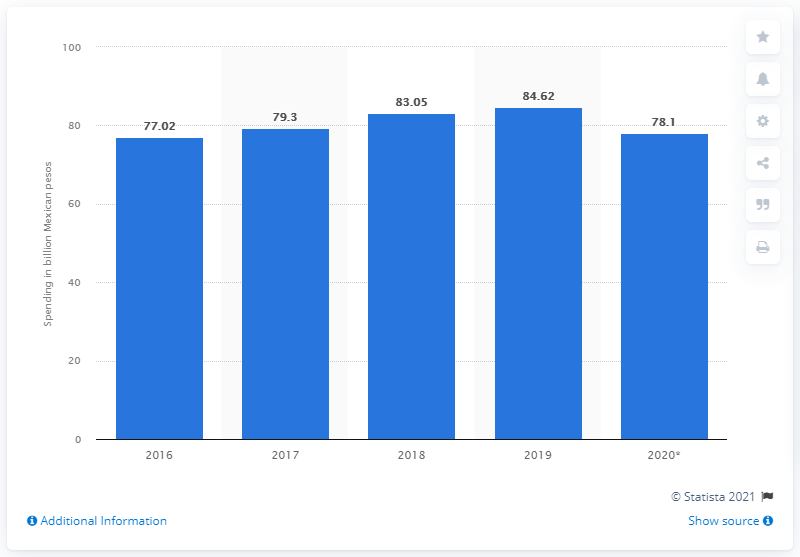Identify some key points in this picture. In 2019, Mexico spent approximately 84.62 on advertising. In 2020, advertising spending in Mexico is expected to reach approximately 78.1 pesos. 